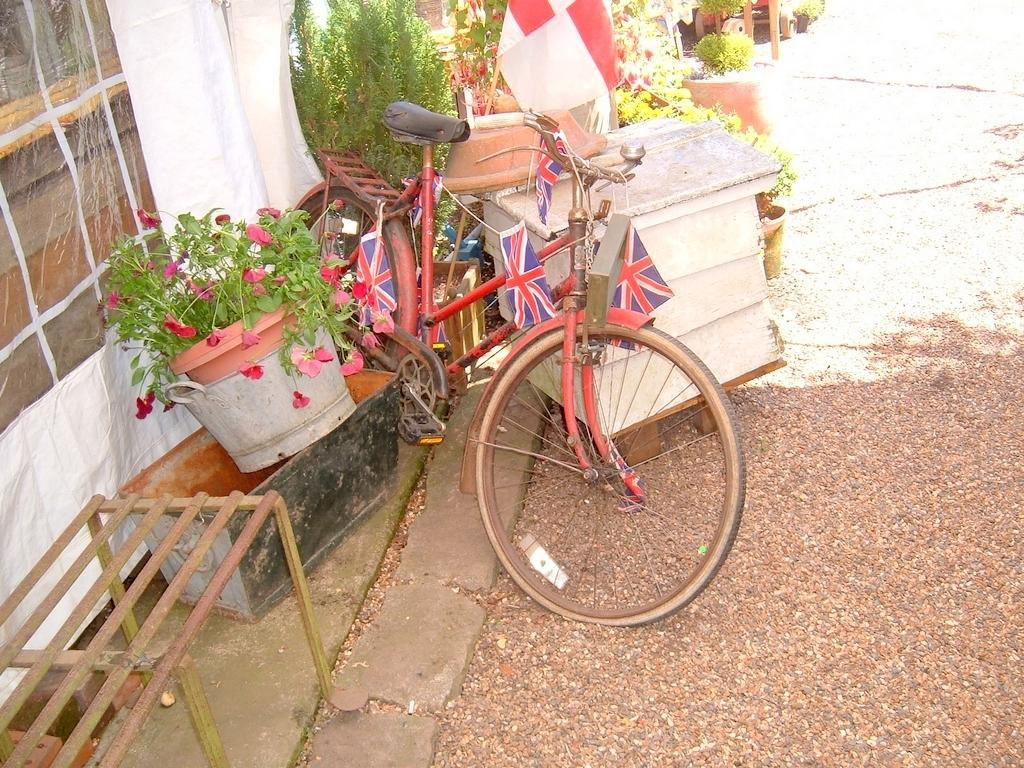What is the main object in the picture? There is a bicycle in the picture. What else can be seen in the picture besides the bicycle? There are flags, a bench, plants, flowers, and a cloth in the picture. Can you describe the flags in the picture? The flags are in the picture, but their specific design or color is not mentioned in the facts. What type of plants are in the picture? The facts mention that there are plants in the picture, but their specific type is not mentioned. What is the purpose of the cloth in the picture? The purpose of the cloth in the picture is not mentioned in the facts. What type of oil is being used to lubricate the bicycle chain in the picture? There is no mention of oil or the bicycle chain being lubricated in the facts, so we cannot answer this question. 